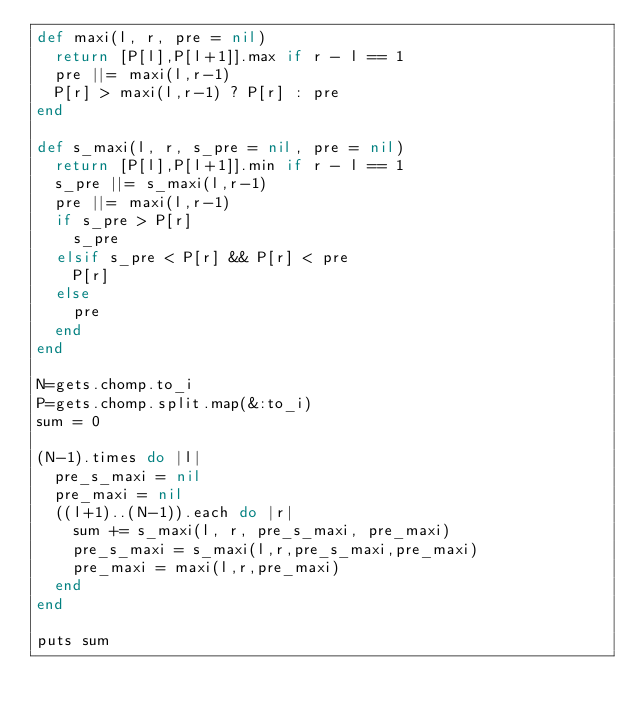<code> <loc_0><loc_0><loc_500><loc_500><_Ruby_>def maxi(l, r, pre = nil)
  return [P[l],P[l+1]].max if r - l == 1 
  pre ||= maxi(l,r-1)
  P[r] > maxi(l,r-1) ? P[r] : pre
end

def s_maxi(l, r, s_pre = nil, pre = nil)
  return [P[l],P[l+1]].min if r - l == 1 
  s_pre ||= s_maxi(l,r-1)
  pre ||= maxi(l,r-1)
  if s_pre > P[r]
    s_pre
  elsif s_pre < P[r] && P[r] < pre
    P[r]
  else
    pre
  end
end

N=gets.chomp.to_i
P=gets.chomp.split.map(&:to_i)
sum = 0

(N-1).times do |l|
  pre_s_maxi = nil
  pre_maxi = nil
  ((l+1)..(N-1)).each do |r|
    sum += s_maxi(l, r, pre_s_maxi, pre_maxi)
    pre_s_maxi = s_maxi(l,r,pre_s_maxi,pre_maxi)
    pre_maxi = maxi(l,r,pre_maxi)
  end
end

puts sum</code> 